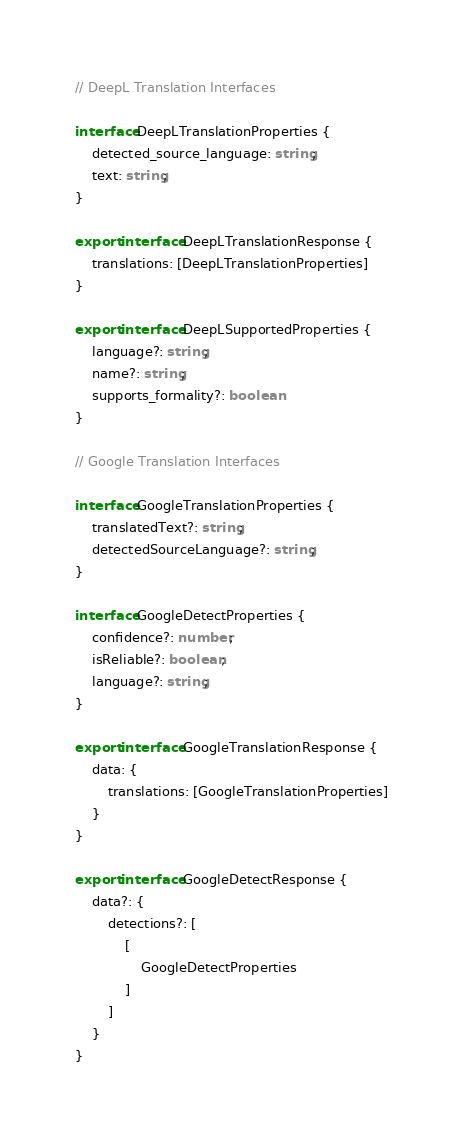<code> <loc_0><loc_0><loc_500><loc_500><_TypeScript_>// DeepL Translation Interfaces

interface DeepLTranslationProperties {
	detected_source_language: string;
	text: string;
}

export interface DeepLTranslationResponse {
	translations: [DeepLTranslationProperties]
}

export interface DeepLSupportedProperties {
	language?: string;
	name?: string;
	supports_formality?: boolean
}

// Google Translation Interfaces

interface GoogleTranslationProperties {
	translatedText?: string;
	detectedSourceLanguage?: string;
}

interface GoogleDetectProperties {
	confidence?: number;
	isReliable?: boolean;
	language?: string;
}

export interface GoogleTranslationResponse {
	data: {
		translations: [GoogleTranslationProperties]
	}
}

export interface GoogleDetectResponse {
	data?: {
		detections?: [
			[
				GoogleDetectProperties
			]
		]
	}
}</code> 